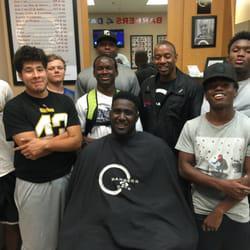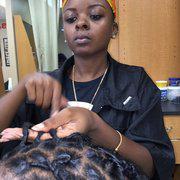The first image is the image on the left, the second image is the image on the right. For the images displayed, is the sentence "The left and right image contains the same number of people in the barber shop with at least one being a woman." factually correct? Answer yes or no. No. 